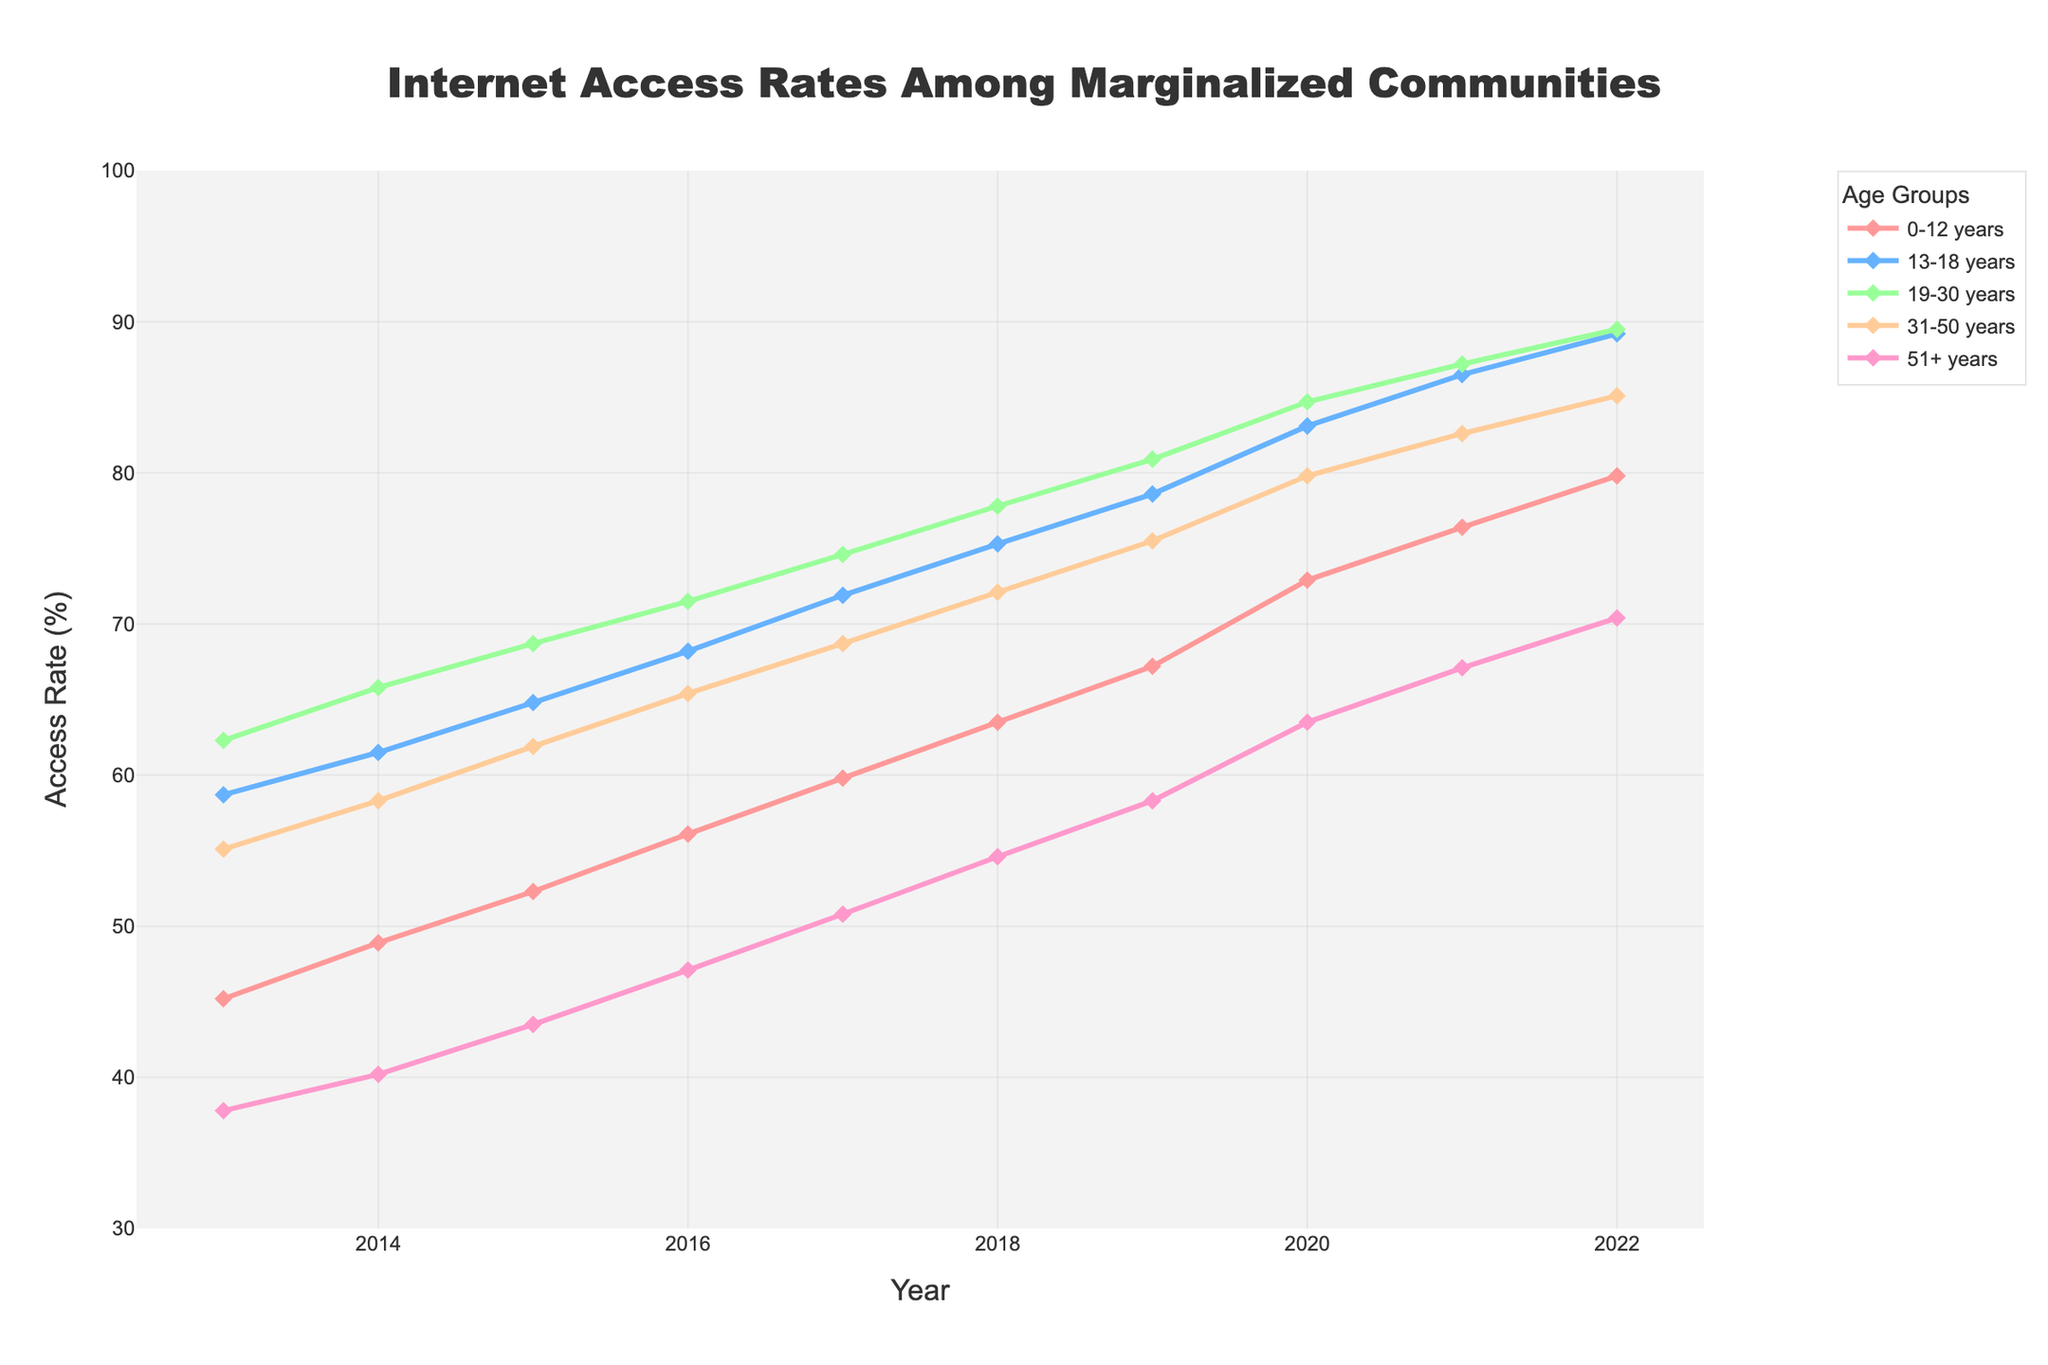What's the overall trend in Internet access rates for the 51+ years age group over the decade? By observing the plot, the line representing the 51+ years age group shows an upward trend from 2013 to 2022. In 2013, the access rate was 37.8%, and it gradually increased each year, reaching 70.4% in 2022.
Answer: Increasing trend In what year did the 19-30 years age group reach an Internet access rate of over 80%? Looking at the line representing the 19-30 years age group, the access rate surpassed 80% in 2019, where it was recorded at 80.9%.
Answer: 2019 Which age group had the highest Internet access rate in 2013? By inspecting the lines for all age groups in 2013, the 19-30 years age group had the highest access rate at 62.3%. Other age groups had lower access rates.
Answer: 19-30 years Compare the Internet access rates for the 0-12 years and 13-18 years age groups in 2020. What is the difference? In 2020, the 0-12 years age group had an access rate of 72.9%, and the 13-18 years age group had an access rate of 83.1%. The difference between these rates is 83.1% - 72.9% = 10.2%.
Answer: 10.2% What's the median Internet access rate for the 31-50 years age group over the decade? The access rates for the 31-50 years age group from 2013 to 2022 are: 55.1, 58.3, 61.9, 65.4, 68.7, 72.1, 75.5, 79.8, 82.6, and 85.1. To find the median, we arrange these values in order (already sorted) and find the middle value. Since there are 10 data points, the median is the average of the 5th and 6th values: (68.7 + 72.1) / 2 = 70.4%.
Answer: 70.4% Between which years did the 0-12 years age group see the largest annual increase in Internet access rates? By examining the increments year by year for the 0-12 years age group: 
2013-2014: 48.9 - 45.2 = 3.7%
2014-2015: 52.3 - 48.9 = 3.4%
2015-2016: 56.1 - 52.3 = 3.8%
2016-2017: 59.8 - 56.1 = 3.7%
2017-2018: 63.5 - 59.8 = 3.7%
2018-2019: 67.2 - 63.5 = 3.7%
2019-2020: 72.9 - 67.2 = 5.7%
2020-2021: 76.4 - 72.9 = 3.5%
2021-2022: 79.8 - 76.4 = 3.4%
The largest increase occurred between 2019 and 2020 with a 5.7% rise.
Answer: 2019-2020 Which age group saw the least improvement in Internet access rate from 2013 to 2022? By comparing the net increase over the decade for each age group:
0-12 years: 79.8 - 45.2 = 34.6%
13-18 years: 89.2 - 58.7 = 30.5%
19-30 years: 89.5 - 62.3 = 27.2%
31-50 years: 85.1 - 55.1 = 30.0%
51+ years: 70.4 - 37.8 = 32.6%
The 19-30 years age group saw the least improvement with a 27.2% increase.
Answer: 19-30 years In which year did the overall access rate for all age groups significantly rise compared to the previous year? (Substantiate with the exact rates) The most significant increase is noticeable from 2019 to 2020 for all age groups, as seen in the sharp rise in the lines. Here are the exact increases for each group:
- 0-12 years: 72.9 - 67.2 = 5.7%
- 13-18 years: 83.1 - 78.6 = 4.5%
- 19-30 years: 84.7 - 80.9 = 3.8%
- 31-50 years: 79.8 - 75.5 = 4.3%
- 51+ years: 63.5 - 58.3 = 5.2%
This indicates a general substantial increase in access rates in 2020 across all groups.
Answer: 2020 